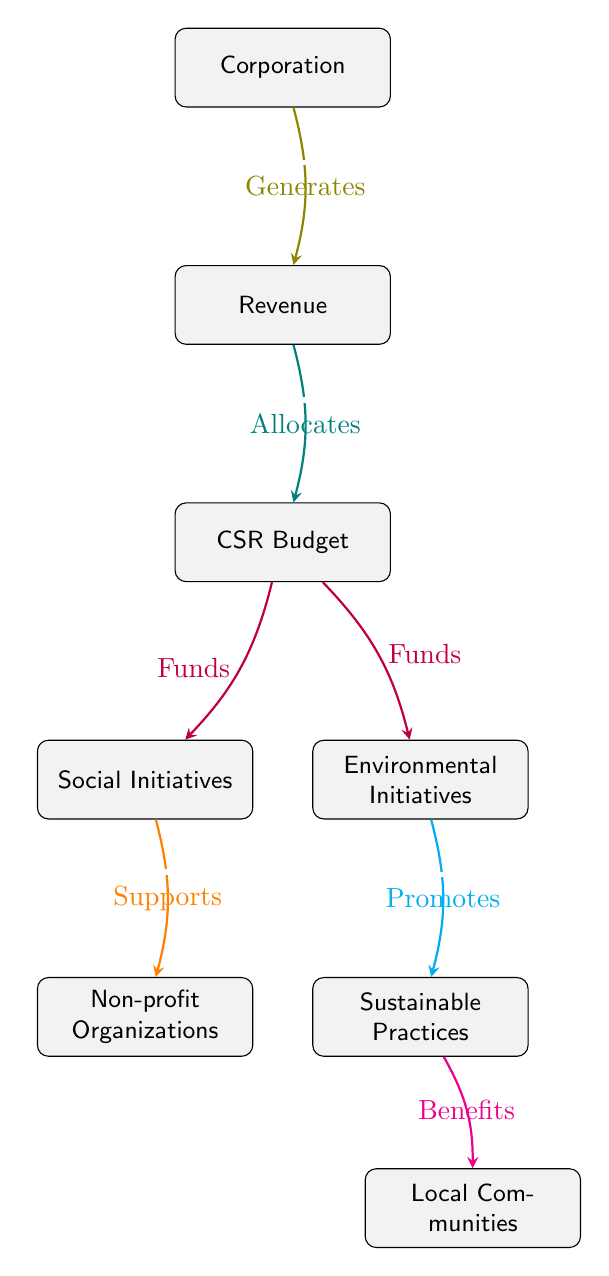What is the first node in the diagram? The first node is labeled "Corporation," indicating it is the starting point for the flow of funds.
Answer: Corporation How many edges are there in the diagram? By counting the connections from one node to another, there are a total of seven edges in the diagram.
Answer: 7 What does the "CSR Budget" node receive? The "CSR Budget" node receives funds, which are transferred to it from the "Revenue" node as indicated by the flow.
Answer: Allocates What do the "Social Initiatives" support? The "Social Initiatives" node supports "Non-profit Organizations," which shows the direction of flow from social initiatives to these organizations.
Answer: Non-profit Organizations What do "Environmental Initiatives" promote? The "Environmental Initiatives" node promotes "Sustainable Practices," as indicated by the flow directed towards sustainable practices.
Answer: Sustainable Practices Which node benefits from "Sustainable Practices"? The node that benefits from "Sustainable Practices" is "Local Communities," demonstrating the positive impact that sustainable practices have on these communities.
Answer: Local Communities What is the relationship between "CSR Budget" and "Social Initiatives"? The relationship between "CSR Budget" and "Social Initiatives" is one of funding, as indicated by the labeled edge stating that CSR Budget funds Social Initiatives.
Answer: Funds Which node does the "Revenue" connect to directly? The "Revenue" node connects directly to the "CSR Budget," indicating the allocation of revenue towards social responsibility initiatives.
Answer: CSR Budget How many types of initiatives are funded by the CSR Budget? The CSR Budget funds two types of initiatives, which are "Social Initiatives" and "Environmental Initiatives," indicating a focus on both areas.
Answer: 2 